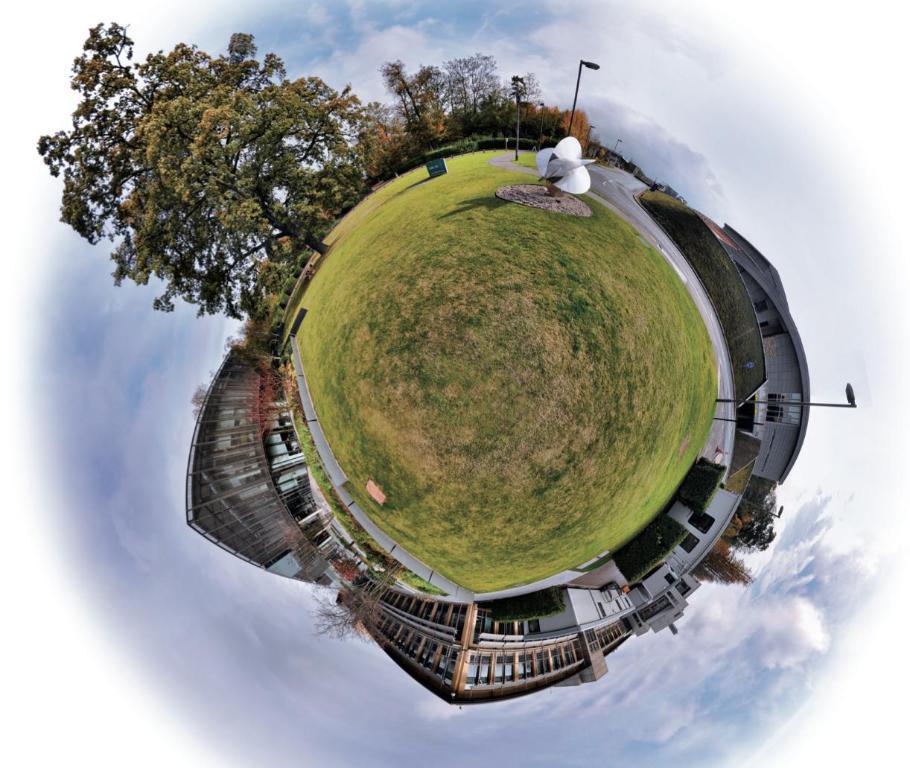How would you summarize this image in a sentence or two? It is a 360 degrees picture. There are many buildings,trees and there is a sculpture in the garden in front of the buildings. 